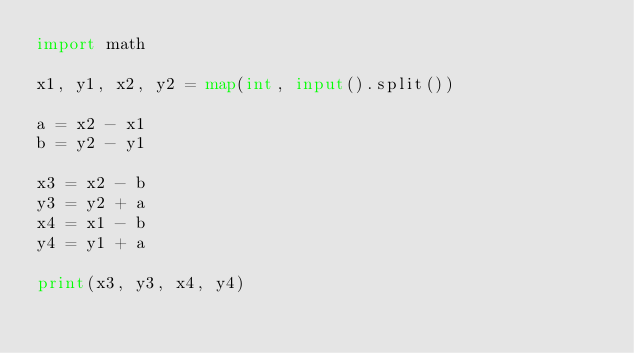<code> <loc_0><loc_0><loc_500><loc_500><_Python_>import math

x1, y1, x2, y2 = map(int, input().split())

a = x2 - x1
b = y2 - y1

x3 = x2 - b
y3 = y2 + a
x4 = x1 - b
y4 = y1 + a

print(x3, y3, x4, y4)
</code> 